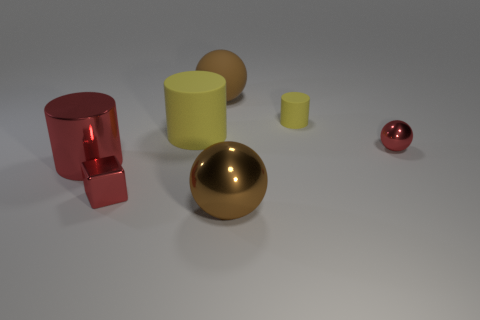Add 2 big red objects. How many objects exist? 9 Subtract all cylinders. How many objects are left? 4 Subtract all big brown spheres. Subtract all large matte cylinders. How many objects are left? 4 Add 5 big red metal cylinders. How many big red metal cylinders are left? 6 Add 5 big brown matte balls. How many big brown matte balls exist? 6 Subtract 0 cyan blocks. How many objects are left? 7 